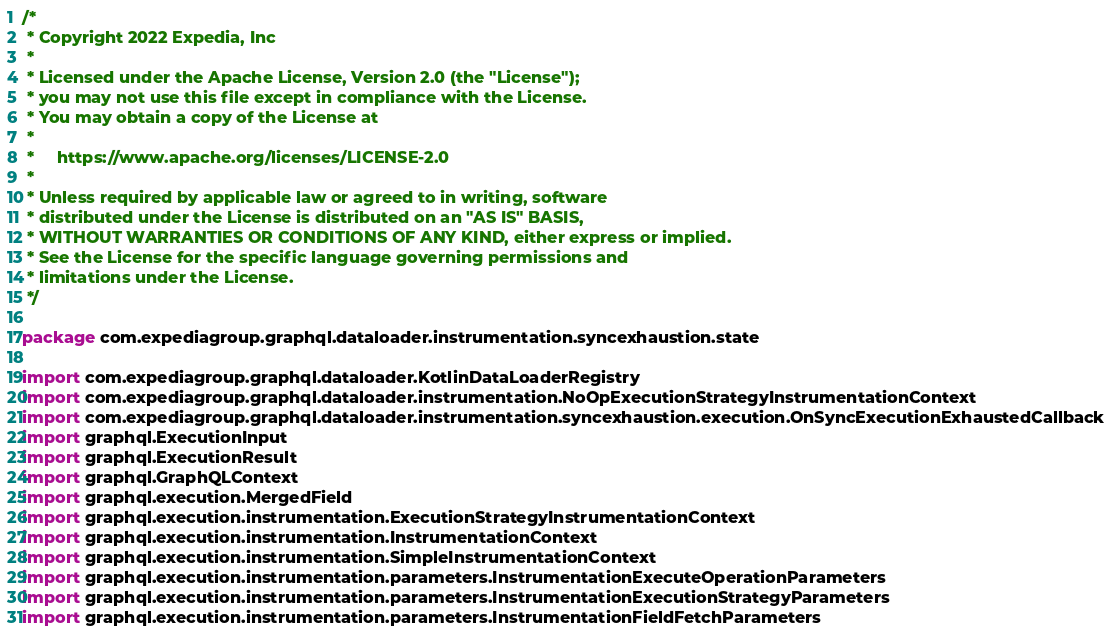<code> <loc_0><loc_0><loc_500><loc_500><_Kotlin_>/*
 * Copyright 2022 Expedia, Inc
 *
 * Licensed under the Apache License, Version 2.0 (the "License");
 * you may not use this file except in compliance with the License.
 * You may obtain a copy of the License at
 *
 *     https://www.apache.org/licenses/LICENSE-2.0
 *
 * Unless required by applicable law or agreed to in writing, software
 * distributed under the License is distributed on an "AS IS" BASIS,
 * WITHOUT WARRANTIES OR CONDITIONS OF ANY KIND, either express or implied.
 * See the License for the specific language governing permissions and
 * limitations under the License.
 */

package com.expediagroup.graphql.dataloader.instrumentation.syncexhaustion.state

import com.expediagroup.graphql.dataloader.KotlinDataLoaderRegistry
import com.expediagroup.graphql.dataloader.instrumentation.NoOpExecutionStrategyInstrumentationContext
import com.expediagroup.graphql.dataloader.instrumentation.syncexhaustion.execution.OnSyncExecutionExhaustedCallback
import graphql.ExecutionInput
import graphql.ExecutionResult
import graphql.GraphQLContext
import graphql.execution.MergedField
import graphql.execution.instrumentation.ExecutionStrategyInstrumentationContext
import graphql.execution.instrumentation.InstrumentationContext
import graphql.execution.instrumentation.SimpleInstrumentationContext
import graphql.execution.instrumentation.parameters.InstrumentationExecuteOperationParameters
import graphql.execution.instrumentation.parameters.InstrumentationExecutionStrategyParameters
import graphql.execution.instrumentation.parameters.InstrumentationFieldFetchParameters</code> 